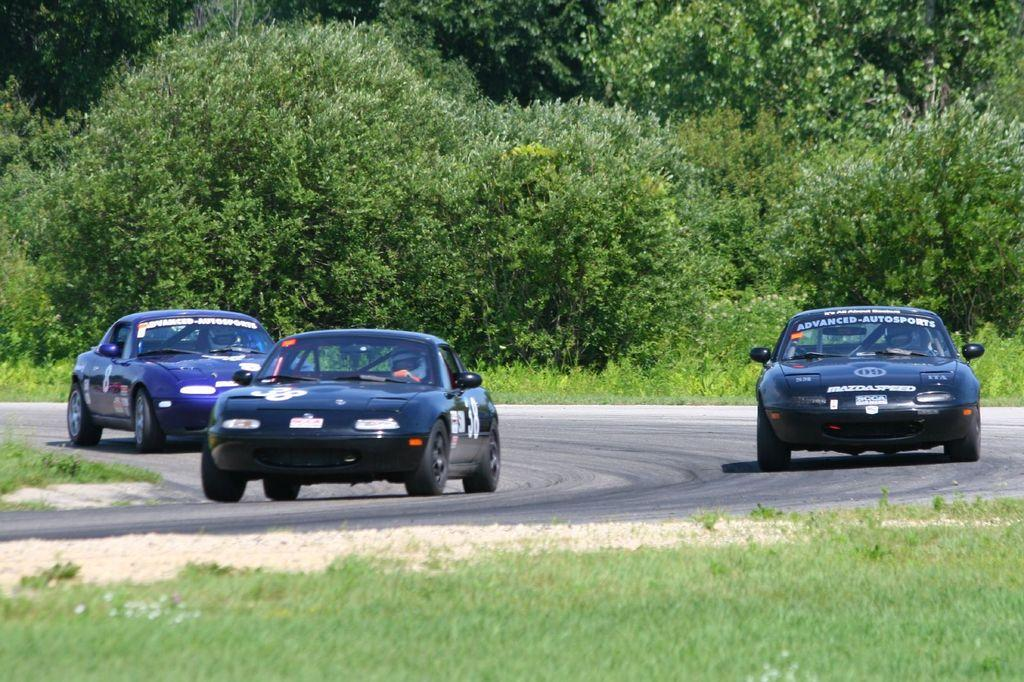What type of vehicles can be seen on the road in the image? There are cars on the road in the image. What natural elements are visible in the image? Trees and grass are present in the image. What type of guide can be seen assisting the cars on the road in the image? There is no guide present in the image; it only shows cars on the road. 